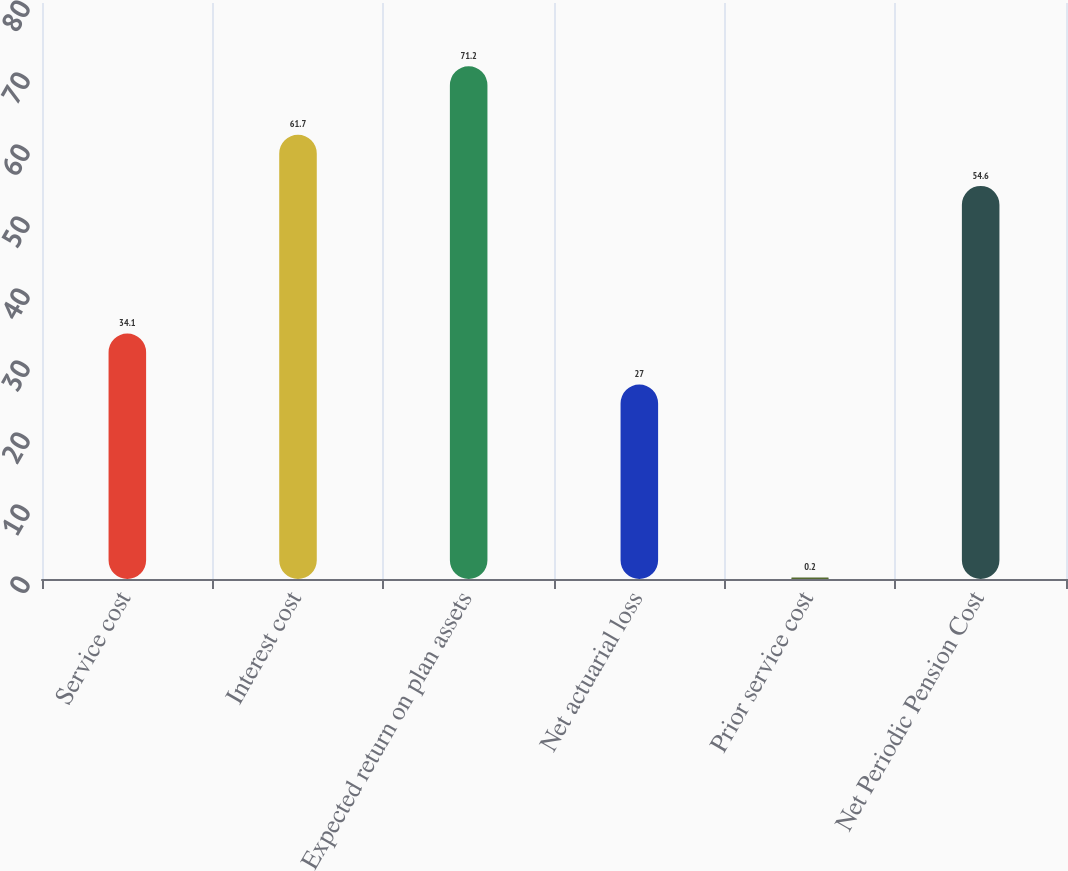Convert chart to OTSL. <chart><loc_0><loc_0><loc_500><loc_500><bar_chart><fcel>Service cost<fcel>Interest cost<fcel>Expected return on plan assets<fcel>Net actuarial loss<fcel>Prior service cost<fcel>Net Periodic Pension Cost<nl><fcel>34.1<fcel>61.7<fcel>71.2<fcel>27<fcel>0.2<fcel>54.6<nl></chart> 